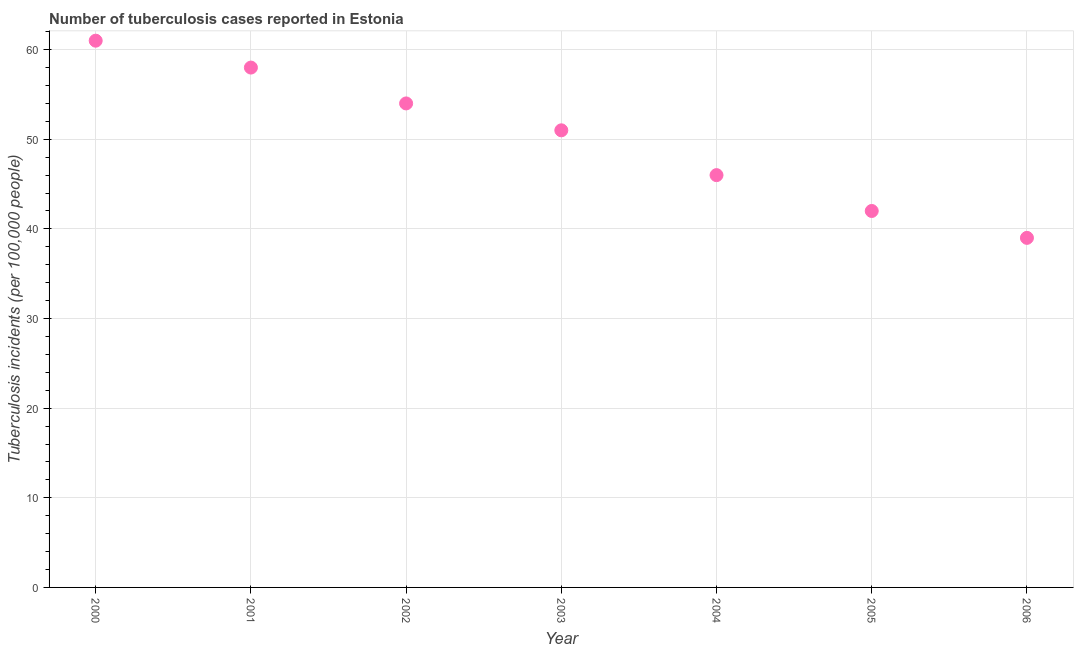What is the number of tuberculosis incidents in 2001?
Offer a terse response. 58. Across all years, what is the maximum number of tuberculosis incidents?
Your answer should be very brief. 61. Across all years, what is the minimum number of tuberculosis incidents?
Provide a succinct answer. 39. What is the sum of the number of tuberculosis incidents?
Provide a short and direct response. 351. What is the difference between the number of tuberculosis incidents in 2003 and 2006?
Offer a very short reply. 12. What is the average number of tuberculosis incidents per year?
Make the answer very short. 50.14. In how many years, is the number of tuberculosis incidents greater than 28 ?
Provide a succinct answer. 7. What is the ratio of the number of tuberculosis incidents in 2003 to that in 2004?
Keep it short and to the point. 1.11. Is the difference between the number of tuberculosis incidents in 2005 and 2006 greater than the difference between any two years?
Provide a short and direct response. No. What is the difference between the highest and the second highest number of tuberculosis incidents?
Ensure brevity in your answer.  3. What is the difference between the highest and the lowest number of tuberculosis incidents?
Provide a short and direct response. 22. Does the number of tuberculosis incidents monotonically increase over the years?
Offer a very short reply. No. How many dotlines are there?
Your response must be concise. 1. How many years are there in the graph?
Provide a short and direct response. 7. What is the difference between two consecutive major ticks on the Y-axis?
Make the answer very short. 10. Are the values on the major ticks of Y-axis written in scientific E-notation?
Offer a very short reply. No. What is the title of the graph?
Provide a succinct answer. Number of tuberculosis cases reported in Estonia. What is the label or title of the Y-axis?
Offer a terse response. Tuberculosis incidents (per 100,0 people). What is the Tuberculosis incidents (per 100,000 people) in 2000?
Ensure brevity in your answer.  61. What is the Tuberculosis incidents (per 100,000 people) in 2002?
Your response must be concise. 54. What is the Tuberculosis incidents (per 100,000 people) in 2003?
Offer a terse response. 51. What is the Tuberculosis incidents (per 100,000 people) in 2005?
Your answer should be compact. 42. What is the Tuberculosis incidents (per 100,000 people) in 2006?
Provide a succinct answer. 39. What is the difference between the Tuberculosis incidents (per 100,000 people) in 2000 and 2006?
Provide a succinct answer. 22. What is the difference between the Tuberculosis incidents (per 100,000 people) in 2001 and 2005?
Give a very brief answer. 16. What is the difference between the Tuberculosis incidents (per 100,000 people) in 2002 and 2003?
Your answer should be very brief. 3. What is the difference between the Tuberculosis incidents (per 100,000 people) in 2002 and 2004?
Your answer should be very brief. 8. What is the difference between the Tuberculosis incidents (per 100,000 people) in 2002 and 2005?
Give a very brief answer. 12. What is the difference between the Tuberculosis incidents (per 100,000 people) in 2002 and 2006?
Offer a terse response. 15. What is the difference between the Tuberculosis incidents (per 100,000 people) in 2003 and 2005?
Offer a terse response. 9. What is the difference between the Tuberculosis incidents (per 100,000 people) in 2004 and 2006?
Provide a short and direct response. 7. What is the difference between the Tuberculosis incidents (per 100,000 people) in 2005 and 2006?
Your answer should be compact. 3. What is the ratio of the Tuberculosis incidents (per 100,000 people) in 2000 to that in 2001?
Make the answer very short. 1.05. What is the ratio of the Tuberculosis incidents (per 100,000 people) in 2000 to that in 2002?
Your response must be concise. 1.13. What is the ratio of the Tuberculosis incidents (per 100,000 people) in 2000 to that in 2003?
Your answer should be very brief. 1.2. What is the ratio of the Tuberculosis incidents (per 100,000 people) in 2000 to that in 2004?
Make the answer very short. 1.33. What is the ratio of the Tuberculosis incidents (per 100,000 people) in 2000 to that in 2005?
Your answer should be compact. 1.45. What is the ratio of the Tuberculosis incidents (per 100,000 people) in 2000 to that in 2006?
Ensure brevity in your answer.  1.56. What is the ratio of the Tuberculosis incidents (per 100,000 people) in 2001 to that in 2002?
Offer a very short reply. 1.07. What is the ratio of the Tuberculosis incidents (per 100,000 people) in 2001 to that in 2003?
Ensure brevity in your answer.  1.14. What is the ratio of the Tuberculosis incidents (per 100,000 people) in 2001 to that in 2004?
Keep it short and to the point. 1.26. What is the ratio of the Tuberculosis incidents (per 100,000 people) in 2001 to that in 2005?
Your answer should be very brief. 1.38. What is the ratio of the Tuberculosis incidents (per 100,000 people) in 2001 to that in 2006?
Provide a short and direct response. 1.49. What is the ratio of the Tuberculosis incidents (per 100,000 people) in 2002 to that in 2003?
Your answer should be very brief. 1.06. What is the ratio of the Tuberculosis incidents (per 100,000 people) in 2002 to that in 2004?
Ensure brevity in your answer.  1.17. What is the ratio of the Tuberculosis incidents (per 100,000 people) in 2002 to that in 2005?
Ensure brevity in your answer.  1.29. What is the ratio of the Tuberculosis incidents (per 100,000 people) in 2002 to that in 2006?
Give a very brief answer. 1.39. What is the ratio of the Tuberculosis incidents (per 100,000 people) in 2003 to that in 2004?
Give a very brief answer. 1.11. What is the ratio of the Tuberculosis incidents (per 100,000 people) in 2003 to that in 2005?
Ensure brevity in your answer.  1.21. What is the ratio of the Tuberculosis incidents (per 100,000 people) in 2003 to that in 2006?
Keep it short and to the point. 1.31. What is the ratio of the Tuberculosis incidents (per 100,000 people) in 2004 to that in 2005?
Your answer should be compact. 1.09. What is the ratio of the Tuberculosis incidents (per 100,000 people) in 2004 to that in 2006?
Provide a succinct answer. 1.18. What is the ratio of the Tuberculosis incidents (per 100,000 people) in 2005 to that in 2006?
Provide a succinct answer. 1.08. 